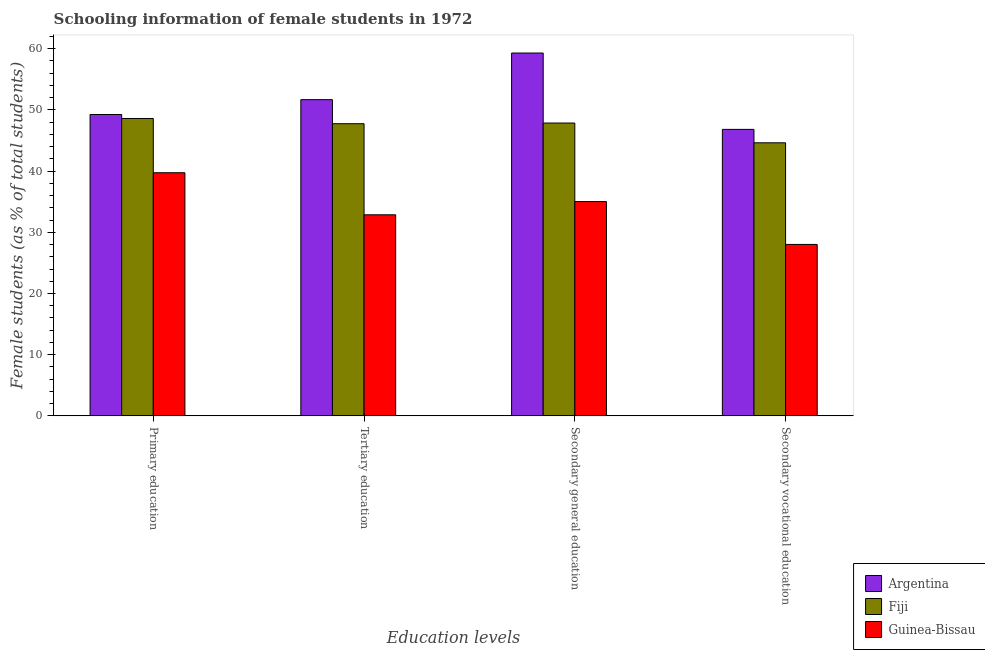Are the number of bars per tick equal to the number of legend labels?
Offer a terse response. Yes. Are the number of bars on each tick of the X-axis equal?
Your response must be concise. Yes. How many bars are there on the 3rd tick from the left?
Ensure brevity in your answer.  3. What is the percentage of female students in tertiary education in Fiji?
Provide a succinct answer. 47.75. Across all countries, what is the maximum percentage of female students in secondary vocational education?
Ensure brevity in your answer.  46.82. Across all countries, what is the minimum percentage of female students in secondary education?
Your answer should be very brief. 35.02. In which country was the percentage of female students in secondary vocational education minimum?
Your response must be concise. Guinea-Bissau. What is the total percentage of female students in tertiary education in the graph?
Provide a short and direct response. 132.29. What is the difference between the percentage of female students in secondary education in Guinea-Bissau and that in Fiji?
Your answer should be compact. -12.84. What is the difference between the percentage of female students in secondary vocational education in Guinea-Bissau and the percentage of female students in secondary education in Fiji?
Offer a terse response. -19.84. What is the average percentage of female students in secondary vocational education per country?
Offer a terse response. 39.82. What is the difference between the percentage of female students in secondary education and percentage of female students in tertiary education in Guinea-Bissau?
Your answer should be very brief. 2.16. In how many countries, is the percentage of female students in secondary vocational education greater than 18 %?
Your answer should be compact. 3. What is the ratio of the percentage of female students in secondary education in Argentina to that in Fiji?
Keep it short and to the point. 1.24. What is the difference between the highest and the second highest percentage of female students in secondary education?
Your answer should be very brief. 11.44. What is the difference between the highest and the lowest percentage of female students in primary education?
Your answer should be very brief. 9.52. Is the sum of the percentage of female students in tertiary education in Argentina and Guinea-Bissau greater than the maximum percentage of female students in primary education across all countries?
Keep it short and to the point. Yes. Is it the case that in every country, the sum of the percentage of female students in primary education and percentage of female students in tertiary education is greater than the sum of percentage of female students in secondary vocational education and percentage of female students in secondary education?
Provide a succinct answer. No. What does the 1st bar from the left in Primary education represents?
Provide a succinct answer. Argentina. What does the 2nd bar from the right in Primary education represents?
Your answer should be compact. Fiji. How many bars are there?
Your answer should be very brief. 12. How many countries are there in the graph?
Provide a succinct answer. 3. What is the difference between two consecutive major ticks on the Y-axis?
Ensure brevity in your answer.  10. Are the values on the major ticks of Y-axis written in scientific E-notation?
Your answer should be very brief. No. Does the graph contain any zero values?
Make the answer very short. No. Does the graph contain grids?
Your answer should be compact. No. Where does the legend appear in the graph?
Provide a short and direct response. Bottom right. How many legend labels are there?
Ensure brevity in your answer.  3. How are the legend labels stacked?
Provide a short and direct response. Vertical. What is the title of the graph?
Offer a very short reply. Schooling information of female students in 1972. What is the label or title of the X-axis?
Ensure brevity in your answer.  Education levels. What is the label or title of the Y-axis?
Provide a succinct answer. Female students (as % of total students). What is the Female students (as % of total students) of Argentina in Primary education?
Ensure brevity in your answer.  49.25. What is the Female students (as % of total students) in Fiji in Primary education?
Make the answer very short. 48.6. What is the Female students (as % of total students) of Guinea-Bissau in Primary education?
Your answer should be compact. 39.73. What is the Female students (as % of total students) in Argentina in Tertiary education?
Offer a terse response. 51.68. What is the Female students (as % of total students) in Fiji in Tertiary education?
Your answer should be compact. 47.75. What is the Female students (as % of total students) of Guinea-Bissau in Tertiary education?
Provide a succinct answer. 32.86. What is the Female students (as % of total students) of Argentina in Secondary general education?
Your answer should be compact. 59.3. What is the Female students (as % of total students) in Fiji in Secondary general education?
Ensure brevity in your answer.  47.86. What is the Female students (as % of total students) of Guinea-Bissau in Secondary general education?
Offer a very short reply. 35.02. What is the Female students (as % of total students) in Argentina in Secondary vocational education?
Your answer should be compact. 46.82. What is the Female students (as % of total students) in Fiji in Secondary vocational education?
Provide a short and direct response. 44.63. What is the Female students (as % of total students) in Guinea-Bissau in Secondary vocational education?
Your answer should be compact. 28.02. Across all Education levels, what is the maximum Female students (as % of total students) in Argentina?
Provide a succinct answer. 59.3. Across all Education levels, what is the maximum Female students (as % of total students) in Fiji?
Your response must be concise. 48.6. Across all Education levels, what is the maximum Female students (as % of total students) in Guinea-Bissau?
Offer a terse response. 39.73. Across all Education levels, what is the minimum Female students (as % of total students) of Argentina?
Ensure brevity in your answer.  46.82. Across all Education levels, what is the minimum Female students (as % of total students) in Fiji?
Make the answer very short. 44.63. Across all Education levels, what is the minimum Female students (as % of total students) in Guinea-Bissau?
Provide a short and direct response. 28.02. What is the total Female students (as % of total students) of Argentina in the graph?
Your answer should be very brief. 207.06. What is the total Female students (as % of total students) in Fiji in the graph?
Your answer should be very brief. 188.84. What is the total Female students (as % of total students) in Guinea-Bissau in the graph?
Your answer should be very brief. 135.64. What is the difference between the Female students (as % of total students) of Argentina in Primary education and that in Tertiary education?
Ensure brevity in your answer.  -2.43. What is the difference between the Female students (as % of total students) of Fiji in Primary education and that in Tertiary education?
Give a very brief answer. 0.85. What is the difference between the Female students (as % of total students) of Guinea-Bissau in Primary education and that in Tertiary education?
Your answer should be very brief. 6.87. What is the difference between the Female students (as % of total students) in Argentina in Primary education and that in Secondary general education?
Provide a succinct answer. -10.05. What is the difference between the Female students (as % of total students) of Fiji in Primary education and that in Secondary general education?
Offer a terse response. 0.74. What is the difference between the Female students (as % of total students) of Guinea-Bissau in Primary education and that in Secondary general education?
Give a very brief answer. 4.71. What is the difference between the Female students (as % of total students) of Argentina in Primary education and that in Secondary vocational education?
Your response must be concise. 2.43. What is the difference between the Female students (as % of total students) in Fiji in Primary education and that in Secondary vocational education?
Make the answer very short. 3.98. What is the difference between the Female students (as % of total students) of Guinea-Bissau in Primary education and that in Secondary vocational education?
Your response must be concise. 11.71. What is the difference between the Female students (as % of total students) in Argentina in Tertiary education and that in Secondary general education?
Provide a short and direct response. -7.62. What is the difference between the Female students (as % of total students) of Fiji in Tertiary education and that in Secondary general education?
Make the answer very short. -0.11. What is the difference between the Female students (as % of total students) in Guinea-Bissau in Tertiary education and that in Secondary general education?
Ensure brevity in your answer.  -2.16. What is the difference between the Female students (as % of total students) in Argentina in Tertiary education and that in Secondary vocational education?
Your answer should be very brief. 4.86. What is the difference between the Female students (as % of total students) in Fiji in Tertiary education and that in Secondary vocational education?
Your response must be concise. 3.12. What is the difference between the Female students (as % of total students) in Guinea-Bissau in Tertiary education and that in Secondary vocational education?
Offer a terse response. 4.84. What is the difference between the Female students (as % of total students) in Argentina in Secondary general education and that in Secondary vocational education?
Offer a terse response. 12.48. What is the difference between the Female students (as % of total students) of Fiji in Secondary general education and that in Secondary vocational education?
Make the answer very short. 3.23. What is the difference between the Female students (as % of total students) in Guinea-Bissau in Secondary general education and that in Secondary vocational education?
Ensure brevity in your answer.  7. What is the difference between the Female students (as % of total students) in Argentina in Primary education and the Female students (as % of total students) in Fiji in Tertiary education?
Ensure brevity in your answer.  1.5. What is the difference between the Female students (as % of total students) of Argentina in Primary education and the Female students (as % of total students) of Guinea-Bissau in Tertiary education?
Give a very brief answer. 16.39. What is the difference between the Female students (as % of total students) in Fiji in Primary education and the Female students (as % of total students) in Guinea-Bissau in Tertiary education?
Keep it short and to the point. 15.74. What is the difference between the Female students (as % of total students) in Argentina in Primary education and the Female students (as % of total students) in Fiji in Secondary general education?
Give a very brief answer. 1.4. What is the difference between the Female students (as % of total students) of Argentina in Primary education and the Female students (as % of total students) of Guinea-Bissau in Secondary general education?
Make the answer very short. 14.23. What is the difference between the Female students (as % of total students) in Fiji in Primary education and the Female students (as % of total students) in Guinea-Bissau in Secondary general education?
Offer a very short reply. 13.58. What is the difference between the Female students (as % of total students) in Argentina in Primary education and the Female students (as % of total students) in Fiji in Secondary vocational education?
Your response must be concise. 4.63. What is the difference between the Female students (as % of total students) of Argentina in Primary education and the Female students (as % of total students) of Guinea-Bissau in Secondary vocational education?
Offer a very short reply. 21.24. What is the difference between the Female students (as % of total students) in Fiji in Primary education and the Female students (as % of total students) in Guinea-Bissau in Secondary vocational education?
Offer a very short reply. 20.58. What is the difference between the Female students (as % of total students) of Argentina in Tertiary education and the Female students (as % of total students) of Fiji in Secondary general education?
Your answer should be compact. 3.82. What is the difference between the Female students (as % of total students) in Argentina in Tertiary education and the Female students (as % of total students) in Guinea-Bissau in Secondary general education?
Make the answer very short. 16.66. What is the difference between the Female students (as % of total students) in Fiji in Tertiary education and the Female students (as % of total students) in Guinea-Bissau in Secondary general education?
Ensure brevity in your answer.  12.73. What is the difference between the Female students (as % of total students) in Argentina in Tertiary education and the Female students (as % of total students) in Fiji in Secondary vocational education?
Make the answer very short. 7.05. What is the difference between the Female students (as % of total students) in Argentina in Tertiary education and the Female students (as % of total students) in Guinea-Bissau in Secondary vocational education?
Keep it short and to the point. 23.66. What is the difference between the Female students (as % of total students) of Fiji in Tertiary education and the Female students (as % of total students) of Guinea-Bissau in Secondary vocational education?
Offer a terse response. 19.73. What is the difference between the Female students (as % of total students) of Argentina in Secondary general education and the Female students (as % of total students) of Fiji in Secondary vocational education?
Keep it short and to the point. 14.68. What is the difference between the Female students (as % of total students) of Argentina in Secondary general education and the Female students (as % of total students) of Guinea-Bissau in Secondary vocational education?
Make the answer very short. 31.28. What is the difference between the Female students (as % of total students) of Fiji in Secondary general education and the Female students (as % of total students) of Guinea-Bissau in Secondary vocational education?
Your answer should be compact. 19.84. What is the average Female students (as % of total students) of Argentina per Education levels?
Make the answer very short. 51.76. What is the average Female students (as % of total students) of Fiji per Education levels?
Provide a short and direct response. 47.21. What is the average Female students (as % of total students) of Guinea-Bissau per Education levels?
Your answer should be compact. 33.91. What is the difference between the Female students (as % of total students) in Argentina and Female students (as % of total students) in Fiji in Primary education?
Provide a succinct answer. 0.65. What is the difference between the Female students (as % of total students) of Argentina and Female students (as % of total students) of Guinea-Bissau in Primary education?
Your answer should be very brief. 9.52. What is the difference between the Female students (as % of total students) in Fiji and Female students (as % of total students) in Guinea-Bissau in Primary education?
Provide a short and direct response. 8.87. What is the difference between the Female students (as % of total students) of Argentina and Female students (as % of total students) of Fiji in Tertiary education?
Your response must be concise. 3.93. What is the difference between the Female students (as % of total students) in Argentina and Female students (as % of total students) in Guinea-Bissau in Tertiary education?
Keep it short and to the point. 18.82. What is the difference between the Female students (as % of total students) of Fiji and Female students (as % of total students) of Guinea-Bissau in Tertiary education?
Provide a short and direct response. 14.89. What is the difference between the Female students (as % of total students) of Argentina and Female students (as % of total students) of Fiji in Secondary general education?
Provide a short and direct response. 11.44. What is the difference between the Female students (as % of total students) of Argentina and Female students (as % of total students) of Guinea-Bissau in Secondary general education?
Make the answer very short. 24.28. What is the difference between the Female students (as % of total students) in Fiji and Female students (as % of total students) in Guinea-Bissau in Secondary general education?
Offer a terse response. 12.84. What is the difference between the Female students (as % of total students) of Argentina and Female students (as % of total students) of Fiji in Secondary vocational education?
Provide a short and direct response. 2.2. What is the difference between the Female students (as % of total students) in Argentina and Female students (as % of total students) in Guinea-Bissau in Secondary vocational education?
Give a very brief answer. 18.8. What is the difference between the Female students (as % of total students) of Fiji and Female students (as % of total students) of Guinea-Bissau in Secondary vocational education?
Ensure brevity in your answer.  16.61. What is the ratio of the Female students (as % of total students) in Argentina in Primary education to that in Tertiary education?
Ensure brevity in your answer.  0.95. What is the ratio of the Female students (as % of total students) of Fiji in Primary education to that in Tertiary education?
Provide a succinct answer. 1.02. What is the ratio of the Female students (as % of total students) of Guinea-Bissau in Primary education to that in Tertiary education?
Make the answer very short. 1.21. What is the ratio of the Female students (as % of total students) of Argentina in Primary education to that in Secondary general education?
Your answer should be compact. 0.83. What is the ratio of the Female students (as % of total students) of Fiji in Primary education to that in Secondary general education?
Your answer should be very brief. 1.02. What is the ratio of the Female students (as % of total students) in Guinea-Bissau in Primary education to that in Secondary general education?
Offer a very short reply. 1.13. What is the ratio of the Female students (as % of total students) in Argentina in Primary education to that in Secondary vocational education?
Provide a short and direct response. 1.05. What is the ratio of the Female students (as % of total students) of Fiji in Primary education to that in Secondary vocational education?
Keep it short and to the point. 1.09. What is the ratio of the Female students (as % of total students) of Guinea-Bissau in Primary education to that in Secondary vocational education?
Give a very brief answer. 1.42. What is the ratio of the Female students (as % of total students) in Argentina in Tertiary education to that in Secondary general education?
Your answer should be compact. 0.87. What is the ratio of the Female students (as % of total students) in Fiji in Tertiary education to that in Secondary general education?
Ensure brevity in your answer.  1. What is the ratio of the Female students (as % of total students) in Guinea-Bissau in Tertiary education to that in Secondary general education?
Offer a terse response. 0.94. What is the ratio of the Female students (as % of total students) of Argentina in Tertiary education to that in Secondary vocational education?
Your answer should be compact. 1.1. What is the ratio of the Female students (as % of total students) in Fiji in Tertiary education to that in Secondary vocational education?
Keep it short and to the point. 1.07. What is the ratio of the Female students (as % of total students) of Guinea-Bissau in Tertiary education to that in Secondary vocational education?
Provide a succinct answer. 1.17. What is the ratio of the Female students (as % of total students) in Argentina in Secondary general education to that in Secondary vocational education?
Provide a short and direct response. 1.27. What is the ratio of the Female students (as % of total students) of Fiji in Secondary general education to that in Secondary vocational education?
Give a very brief answer. 1.07. What is the ratio of the Female students (as % of total students) of Guinea-Bissau in Secondary general education to that in Secondary vocational education?
Ensure brevity in your answer.  1.25. What is the difference between the highest and the second highest Female students (as % of total students) in Argentina?
Your answer should be very brief. 7.62. What is the difference between the highest and the second highest Female students (as % of total students) of Fiji?
Your answer should be compact. 0.74. What is the difference between the highest and the second highest Female students (as % of total students) of Guinea-Bissau?
Offer a very short reply. 4.71. What is the difference between the highest and the lowest Female students (as % of total students) in Argentina?
Give a very brief answer. 12.48. What is the difference between the highest and the lowest Female students (as % of total students) in Fiji?
Your answer should be compact. 3.98. What is the difference between the highest and the lowest Female students (as % of total students) of Guinea-Bissau?
Your response must be concise. 11.71. 